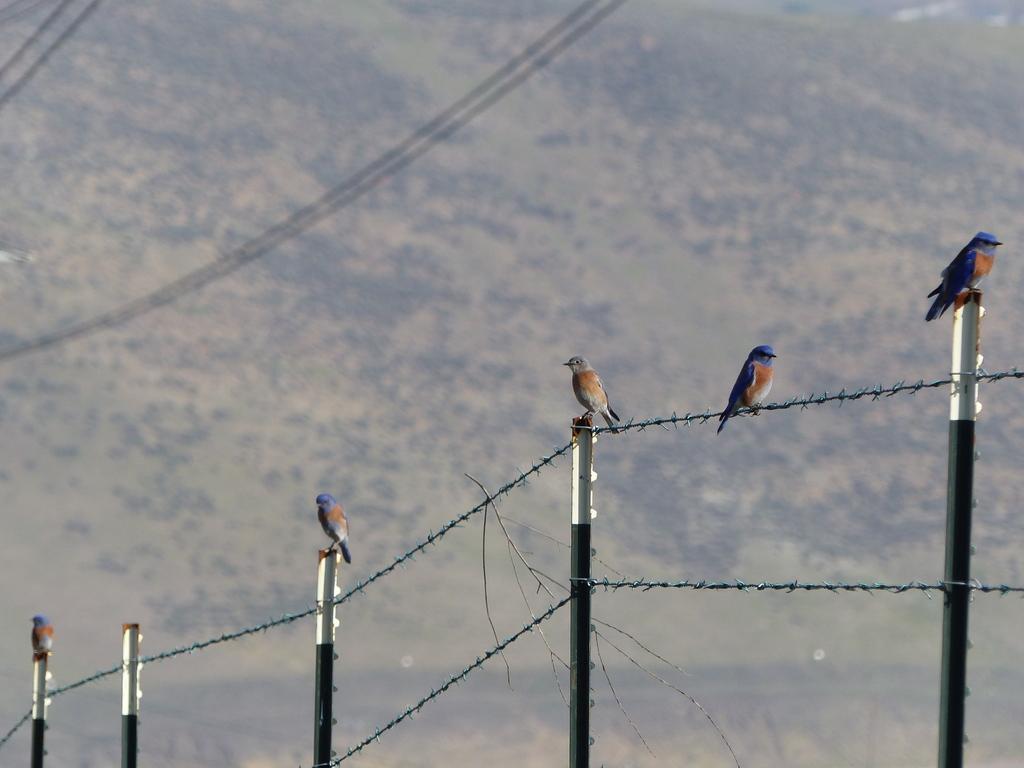Describe this image in one or two sentences. In this picture there is a boundary in the center of the image and there are birds on it and there are wires at the top side of the image and the background area of the image is blur. 